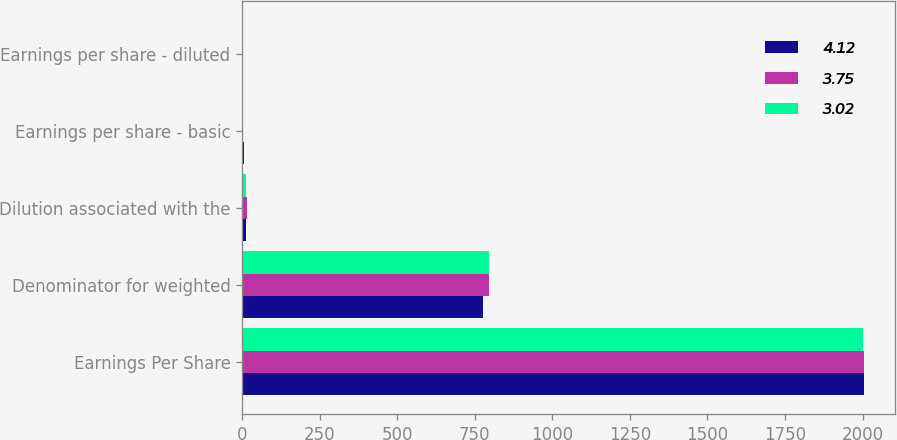<chart> <loc_0><loc_0><loc_500><loc_500><stacked_bar_chart><ecel><fcel>Earnings Per Share<fcel>Denominator for weighted<fcel>Dilution associated with the<fcel>Earnings per share - basic<fcel>Earnings per share - diluted<nl><fcel>4.12<fcel>2005<fcel>776.9<fcel>12<fcel>4.18<fcel>4.12<nl><fcel>3.75<fcel>2004<fcel>796.5<fcel>16<fcel>3.83<fcel>3.75<nl><fcel>3.02<fcel>2003<fcel>795.3<fcel>12.5<fcel>3.07<fcel>3.02<nl></chart> 